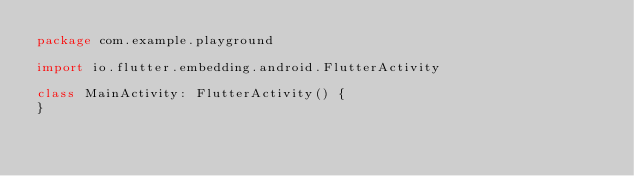Convert code to text. <code><loc_0><loc_0><loc_500><loc_500><_Kotlin_>package com.example.playground

import io.flutter.embedding.android.FlutterActivity

class MainActivity: FlutterActivity() {
}
</code> 